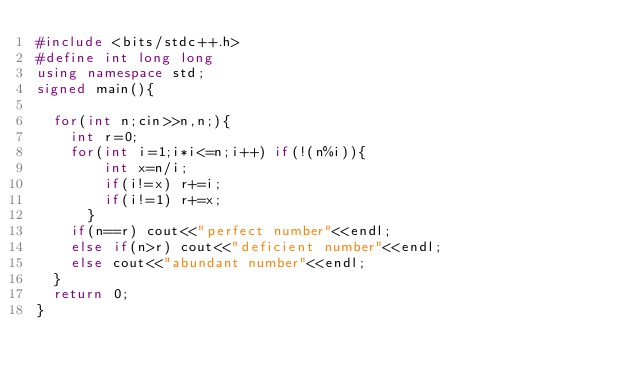<code> <loc_0><loc_0><loc_500><loc_500><_C++_>#include <bits/stdc++.h>
#define int long long
using namespace std;
signed main(){

  for(int n;cin>>n,n;){
    int r=0;
    for(int i=1;i*i<=n;i++) if(!(n%i)){
        int x=n/i;
        if(i!=x) r+=i;
        if(i!=1) r+=x;
      }
    if(n==r) cout<<"perfect number"<<endl;
    else if(n>r) cout<<"deficient number"<<endl;
    else cout<<"abundant number"<<endl;
  }
  return 0;
}</code> 